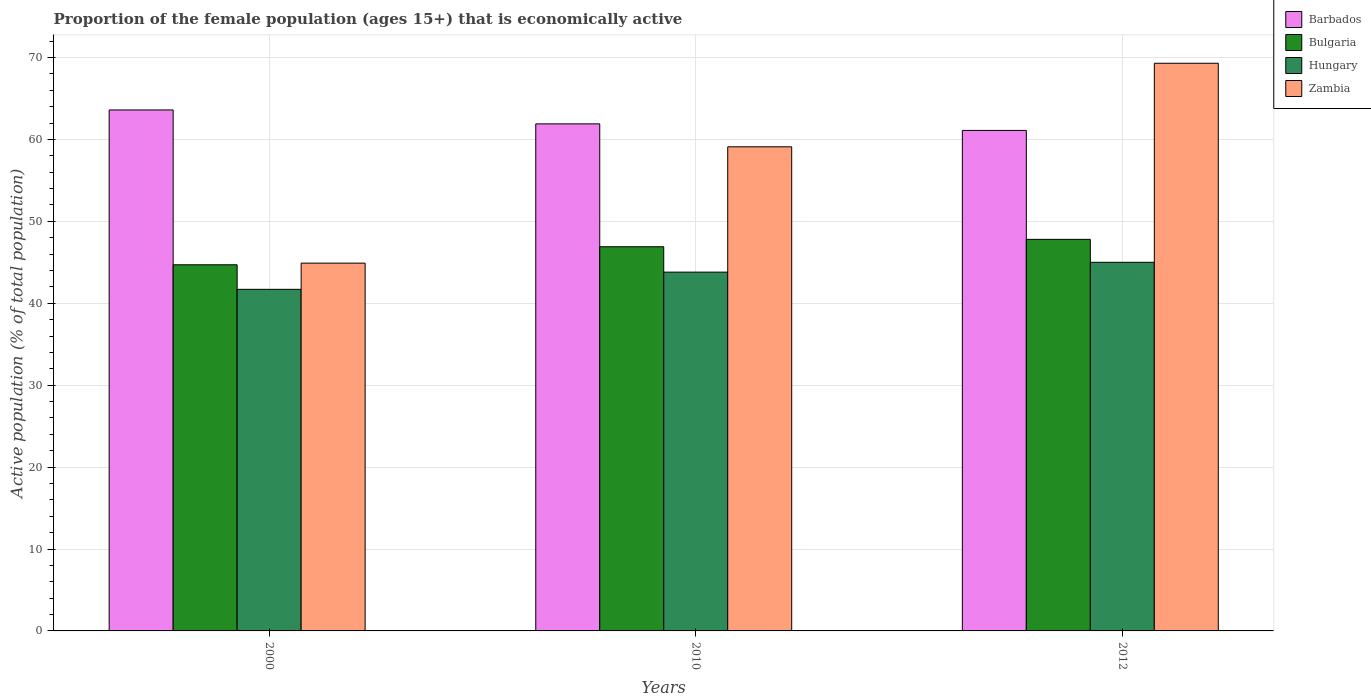How many different coloured bars are there?
Ensure brevity in your answer.  4. How many groups of bars are there?
Your response must be concise. 3. Are the number of bars on each tick of the X-axis equal?
Offer a terse response. Yes. How many bars are there on the 1st tick from the right?
Provide a succinct answer. 4. In how many cases, is the number of bars for a given year not equal to the number of legend labels?
Ensure brevity in your answer.  0. What is the proportion of the female population that is economically active in Bulgaria in 2000?
Your response must be concise. 44.7. Across all years, what is the maximum proportion of the female population that is economically active in Zambia?
Make the answer very short. 69.3. Across all years, what is the minimum proportion of the female population that is economically active in Hungary?
Your answer should be compact. 41.7. In which year was the proportion of the female population that is economically active in Barbados maximum?
Make the answer very short. 2000. In which year was the proportion of the female population that is economically active in Barbados minimum?
Keep it short and to the point. 2012. What is the total proportion of the female population that is economically active in Bulgaria in the graph?
Provide a succinct answer. 139.4. What is the difference between the proportion of the female population that is economically active in Bulgaria in 2000 and that in 2012?
Provide a short and direct response. -3.1. What is the difference between the proportion of the female population that is economically active in Hungary in 2000 and the proportion of the female population that is economically active in Barbados in 2010?
Ensure brevity in your answer.  -20.2. What is the average proportion of the female population that is economically active in Zambia per year?
Your answer should be compact. 57.77. In the year 2010, what is the difference between the proportion of the female population that is economically active in Barbados and proportion of the female population that is economically active in Hungary?
Your answer should be compact. 18.1. In how many years, is the proportion of the female population that is economically active in Hungary greater than 38 %?
Make the answer very short. 3. What is the ratio of the proportion of the female population that is economically active in Zambia in 2010 to that in 2012?
Ensure brevity in your answer.  0.85. What is the difference between the highest and the second highest proportion of the female population that is economically active in Barbados?
Provide a short and direct response. 1.7. What is the difference between the highest and the lowest proportion of the female population that is economically active in Barbados?
Your response must be concise. 2.5. What does the 4th bar from the left in 2010 represents?
Your response must be concise. Zambia. How many bars are there?
Provide a succinct answer. 12. How many years are there in the graph?
Offer a very short reply. 3. Does the graph contain any zero values?
Ensure brevity in your answer.  No. Where does the legend appear in the graph?
Make the answer very short. Top right. What is the title of the graph?
Offer a terse response. Proportion of the female population (ages 15+) that is economically active. Does "Libya" appear as one of the legend labels in the graph?
Keep it short and to the point. No. What is the label or title of the X-axis?
Your response must be concise. Years. What is the label or title of the Y-axis?
Ensure brevity in your answer.  Active population (% of total population). What is the Active population (% of total population) in Barbados in 2000?
Provide a succinct answer. 63.6. What is the Active population (% of total population) of Bulgaria in 2000?
Make the answer very short. 44.7. What is the Active population (% of total population) in Hungary in 2000?
Offer a very short reply. 41.7. What is the Active population (% of total population) in Zambia in 2000?
Your answer should be compact. 44.9. What is the Active population (% of total population) of Barbados in 2010?
Keep it short and to the point. 61.9. What is the Active population (% of total population) of Bulgaria in 2010?
Provide a succinct answer. 46.9. What is the Active population (% of total population) of Hungary in 2010?
Ensure brevity in your answer.  43.8. What is the Active population (% of total population) of Zambia in 2010?
Provide a succinct answer. 59.1. What is the Active population (% of total population) of Barbados in 2012?
Provide a short and direct response. 61.1. What is the Active population (% of total population) of Bulgaria in 2012?
Provide a succinct answer. 47.8. What is the Active population (% of total population) of Zambia in 2012?
Provide a short and direct response. 69.3. Across all years, what is the maximum Active population (% of total population) of Barbados?
Your answer should be very brief. 63.6. Across all years, what is the maximum Active population (% of total population) of Bulgaria?
Give a very brief answer. 47.8. Across all years, what is the maximum Active population (% of total population) in Zambia?
Offer a terse response. 69.3. Across all years, what is the minimum Active population (% of total population) in Barbados?
Your answer should be very brief. 61.1. Across all years, what is the minimum Active population (% of total population) of Bulgaria?
Provide a short and direct response. 44.7. Across all years, what is the minimum Active population (% of total population) of Hungary?
Offer a very short reply. 41.7. Across all years, what is the minimum Active population (% of total population) of Zambia?
Provide a short and direct response. 44.9. What is the total Active population (% of total population) of Barbados in the graph?
Provide a short and direct response. 186.6. What is the total Active population (% of total population) of Bulgaria in the graph?
Offer a very short reply. 139.4. What is the total Active population (% of total population) in Hungary in the graph?
Keep it short and to the point. 130.5. What is the total Active population (% of total population) of Zambia in the graph?
Give a very brief answer. 173.3. What is the difference between the Active population (% of total population) in Bulgaria in 2000 and that in 2010?
Offer a very short reply. -2.2. What is the difference between the Active population (% of total population) in Zambia in 2000 and that in 2010?
Give a very brief answer. -14.2. What is the difference between the Active population (% of total population) of Barbados in 2000 and that in 2012?
Your answer should be very brief. 2.5. What is the difference between the Active population (% of total population) in Bulgaria in 2000 and that in 2012?
Keep it short and to the point. -3.1. What is the difference between the Active population (% of total population) in Zambia in 2000 and that in 2012?
Offer a very short reply. -24.4. What is the difference between the Active population (% of total population) in Barbados in 2010 and that in 2012?
Keep it short and to the point. 0.8. What is the difference between the Active population (% of total population) of Barbados in 2000 and the Active population (% of total population) of Bulgaria in 2010?
Offer a terse response. 16.7. What is the difference between the Active population (% of total population) of Barbados in 2000 and the Active population (% of total population) of Hungary in 2010?
Provide a succinct answer. 19.8. What is the difference between the Active population (% of total population) in Barbados in 2000 and the Active population (% of total population) in Zambia in 2010?
Keep it short and to the point. 4.5. What is the difference between the Active population (% of total population) in Bulgaria in 2000 and the Active population (% of total population) in Zambia in 2010?
Your answer should be compact. -14.4. What is the difference between the Active population (% of total population) in Hungary in 2000 and the Active population (% of total population) in Zambia in 2010?
Make the answer very short. -17.4. What is the difference between the Active population (% of total population) in Barbados in 2000 and the Active population (% of total population) in Hungary in 2012?
Offer a terse response. 18.6. What is the difference between the Active population (% of total population) of Bulgaria in 2000 and the Active population (% of total population) of Zambia in 2012?
Your response must be concise. -24.6. What is the difference between the Active population (% of total population) in Hungary in 2000 and the Active population (% of total population) in Zambia in 2012?
Give a very brief answer. -27.6. What is the difference between the Active population (% of total population) of Bulgaria in 2010 and the Active population (% of total population) of Zambia in 2012?
Give a very brief answer. -22.4. What is the difference between the Active population (% of total population) in Hungary in 2010 and the Active population (% of total population) in Zambia in 2012?
Give a very brief answer. -25.5. What is the average Active population (% of total population) of Barbados per year?
Your answer should be very brief. 62.2. What is the average Active population (% of total population) in Bulgaria per year?
Ensure brevity in your answer.  46.47. What is the average Active population (% of total population) of Hungary per year?
Your answer should be very brief. 43.5. What is the average Active population (% of total population) of Zambia per year?
Ensure brevity in your answer.  57.77. In the year 2000, what is the difference between the Active population (% of total population) in Barbados and Active population (% of total population) in Bulgaria?
Your answer should be compact. 18.9. In the year 2000, what is the difference between the Active population (% of total population) of Barbados and Active population (% of total population) of Hungary?
Give a very brief answer. 21.9. In the year 2000, what is the difference between the Active population (% of total population) of Barbados and Active population (% of total population) of Zambia?
Your answer should be very brief. 18.7. In the year 2000, what is the difference between the Active population (% of total population) of Bulgaria and Active population (% of total population) of Hungary?
Ensure brevity in your answer.  3. In the year 2000, what is the difference between the Active population (% of total population) of Hungary and Active population (% of total population) of Zambia?
Keep it short and to the point. -3.2. In the year 2010, what is the difference between the Active population (% of total population) in Barbados and Active population (% of total population) in Hungary?
Keep it short and to the point. 18.1. In the year 2010, what is the difference between the Active population (% of total population) in Bulgaria and Active population (% of total population) in Hungary?
Offer a terse response. 3.1. In the year 2010, what is the difference between the Active population (% of total population) of Bulgaria and Active population (% of total population) of Zambia?
Provide a succinct answer. -12.2. In the year 2010, what is the difference between the Active population (% of total population) of Hungary and Active population (% of total population) of Zambia?
Ensure brevity in your answer.  -15.3. In the year 2012, what is the difference between the Active population (% of total population) of Barbados and Active population (% of total population) of Bulgaria?
Offer a terse response. 13.3. In the year 2012, what is the difference between the Active population (% of total population) of Barbados and Active population (% of total population) of Zambia?
Make the answer very short. -8.2. In the year 2012, what is the difference between the Active population (% of total population) of Bulgaria and Active population (% of total population) of Zambia?
Your answer should be compact. -21.5. In the year 2012, what is the difference between the Active population (% of total population) in Hungary and Active population (% of total population) in Zambia?
Offer a very short reply. -24.3. What is the ratio of the Active population (% of total population) of Barbados in 2000 to that in 2010?
Your answer should be compact. 1.03. What is the ratio of the Active population (% of total population) in Bulgaria in 2000 to that in 2010?
Your answer should be compact. 0.95. What is the ratio of the Active population (% of total population) of Hungary in 2000 to that in 2010?
Keep it short and to the point. 0.95. What is the ratio of the Active population (% of total population) of Zambia in 2000 to that in 2010?
Keep it short and to the point. 0.76. What is the ratio of the Active population (% of total population) in Barbados in 2000 to that in 2012?
Your answer should be very brief. 1.04. What is the ratio of the Active population (% of total population) of Bulgaria in 2000 to that in 2012?
Your response must be concise. 0.94. What is the ratio of the Active population (% of total population) of Hungary in 2000 to that in 2012?
Make the answer very short. 0.93. What is the ratio of the Active population (% of total population) of Zambia in 2000 to that in 2012?
Ensure brevity in your answer.  0.65. What is the ratio of the Active population (% of total population) of Barbados in 2010 to that in 2012?
Keep it short and to the point. 1.01. What is the ratio of the Active population (% of total population) in Bulgaria in 2010 to that in 2012?
Your answer should be very brief. 0.98. What is the ratio of the Active population (% of total population) in Hungary in 2010 to that in 2012?
Ensure brevity in your answer.  0.97. What is the ratio of the Active population (% of total population) of Zambia in 2010 to that in 2012?
Ensure brevity in your answer.  0.85. What is the difference between the highest and the lowest Active population (% of total population) in Bulgaria?
Give a very brief answer. 3.1. What is the difference between the highest and the lowest Active population (% of total population) in Hungary?
Offer a very short reply. 3.3. What is the difference between the highest and the lowest Active population (% of total population) in Zambia?
Your answer should be compact. 24.4. 